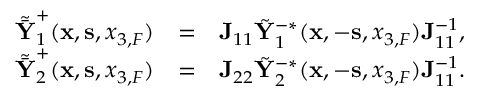<formula> <loc_0><loc_0><loc_500><loc_500>\begin{array} { r l r } { \tilde { \bar { Y } } _ { 1 } ^ { + } ( { x } , { s } , { x _ { 3 , F } } ) } & { = } & { { J } _ { 1 1 } \tilde { Y } _ { 1 } ^ { - * } ( { x } , - { s } , { x _ { 3 , F } } ) { J } _ { 1 1 } ^ { - 1 } , } \\ { \tilde { \bar { Y } } _ { 2 } ^ { + } ( { x } , { s } , { x _ { 3 , F } } ) } & { = } & { { J } _ { 2 2 } \tilde { Y } _ { 2 } ^ { - * } ( { x } , - { s } , { x _ { 3 , F } } ) { J } _ { 1 1 } ^ { - 1 } . } \end{array}</formula> 